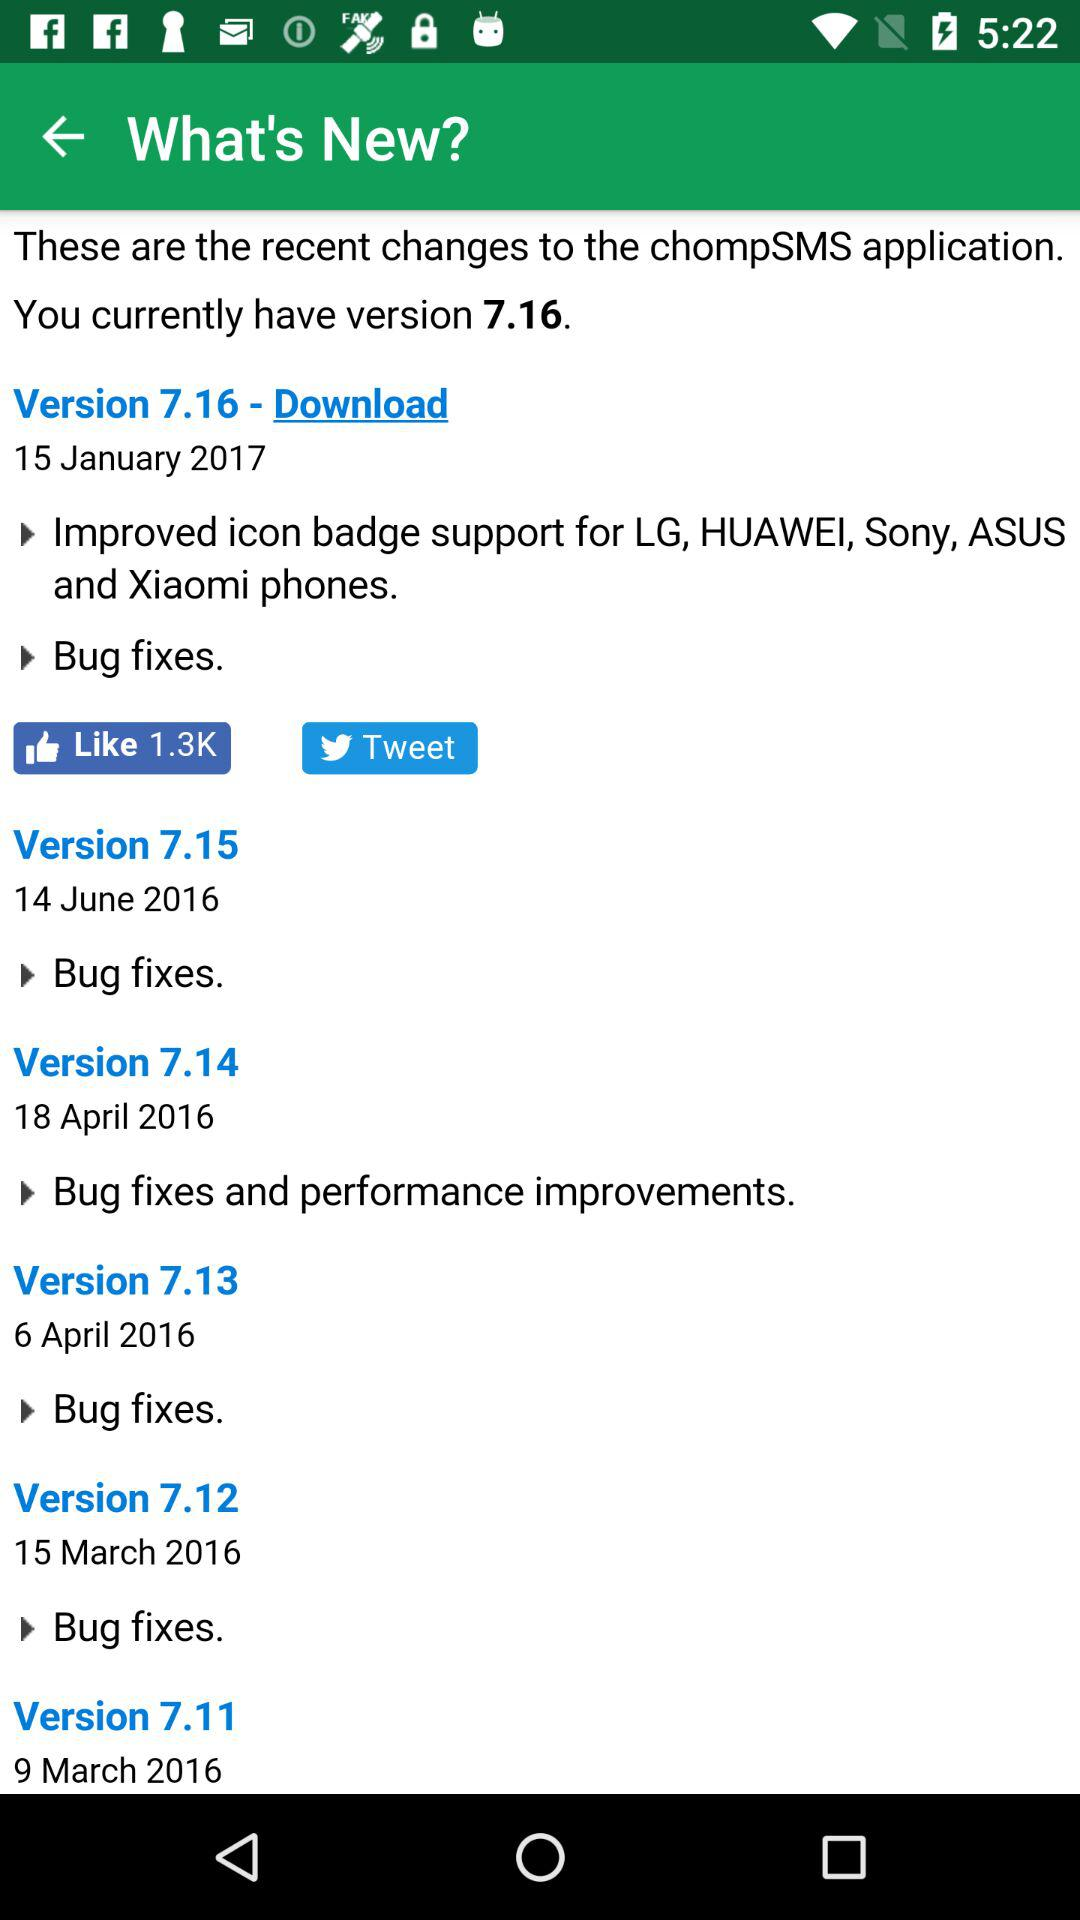What is the status the bugs version 7.12?
When the provided information is insufficient, respond with <no answer>. <no answer> 